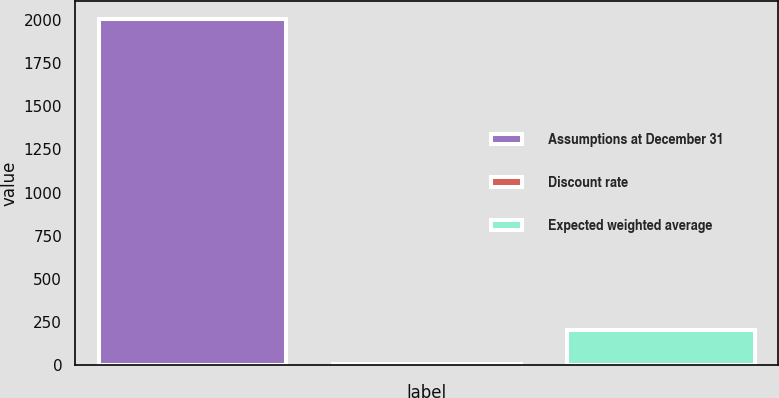Convert chart. <chart><loc_0><loc_0><loc_500><loc_500><bar_chart><fcel>Assumptions at December 31<fcel>Discount rate<fcel>Expected weighted average<nl><fcel>2007<fcel>6.46<fcel>206.51<nl></chart> 